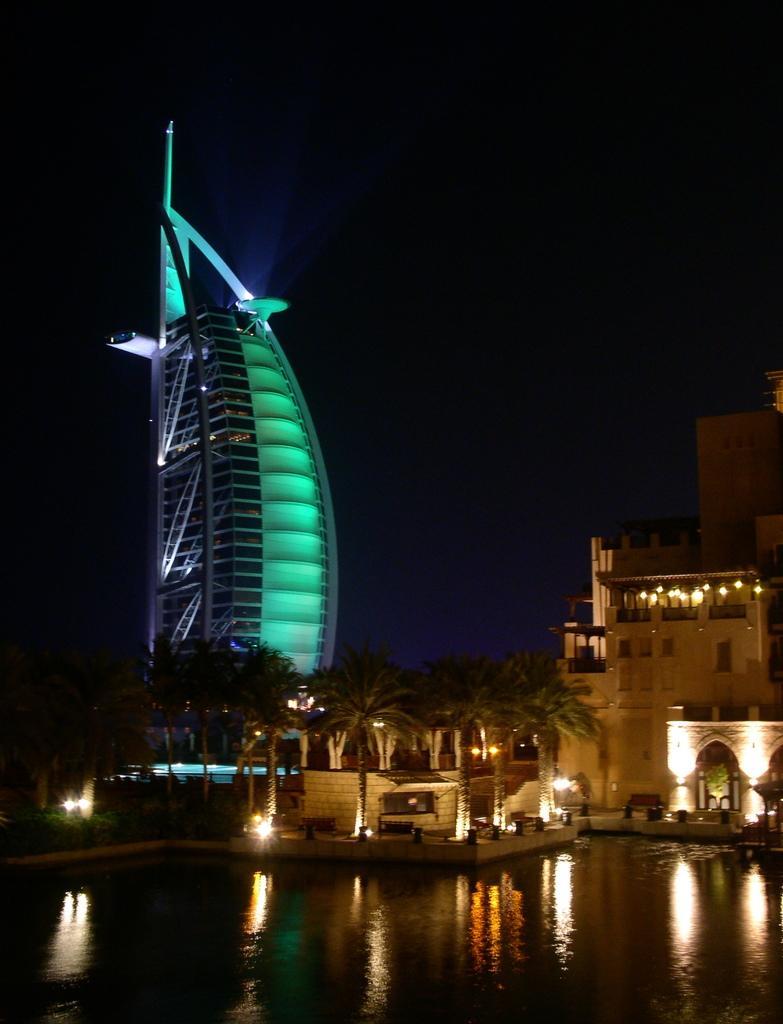Could you give a brief overview of what you see in this image? In this image we can see a glass tower, trees, buildings, lights and other objects. At the top of the image there is the sky. At the bottom of the image there is water. On the water we can see some reflections. 